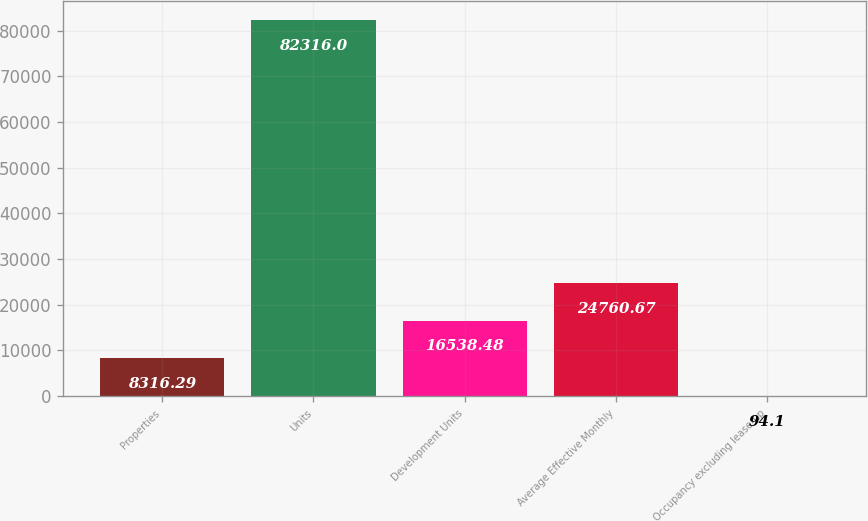Convert chart. <chart><loc_0><loc_0><loc_500><loc_500><bar_chart><fcel>Properties<fcel>Units<fcel>Development Units<fcel>Average Effective Monthly<fcel>Occupancy excluding lease-up<nl><fcel>8316.29<fcel>82316<fcel>16538.5<fcel>24760.7<fcel>94.1<nl></chart> 